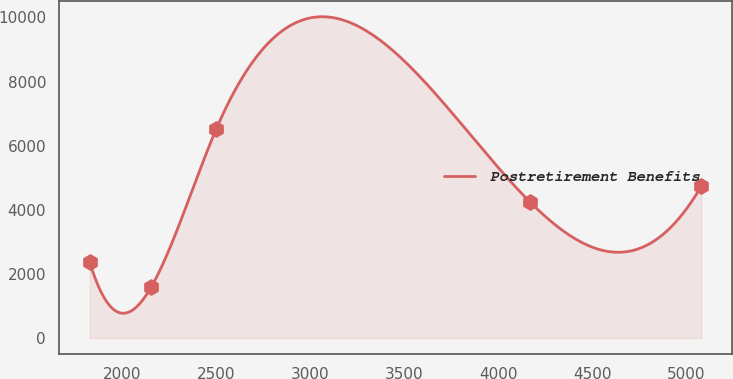Convert chart to OTSL. <chart><loc_0><loc_0><loc_500><loc_500><line_chart><ecel><fcel>Postretirement Benefits<nl><fcel>1826.08<fcel>2359.28<nl><fcel>2151.33<fcel>1578.79<nl><fcel>2497.87<fcel>6506.77<nl><fcel>4170.14<fcel>4230.73<nl><fcel>5078.61<fcel>4737.03<nl></chart> 